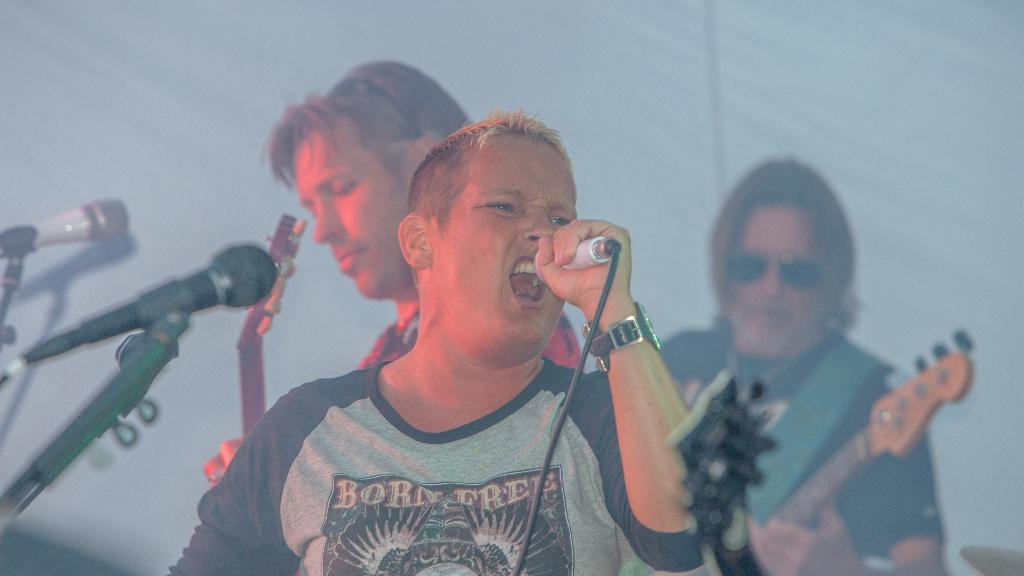What is the man in the image doing? The man is standing and singing in the image. What is the man holding in his hand? The man is holding a microphone in his hand. Are there any other people in the image? Yes, there are two men in the background of the image. What are the two men in the background doing? The two men are standing and playing guitars. How many microphones are present in the image? There are microphones present in the image. How many letters are visible on the minute hand of the clock in the image? There is no clock present in the image, so it is not possible to determine the number of letters on the minute hand. 